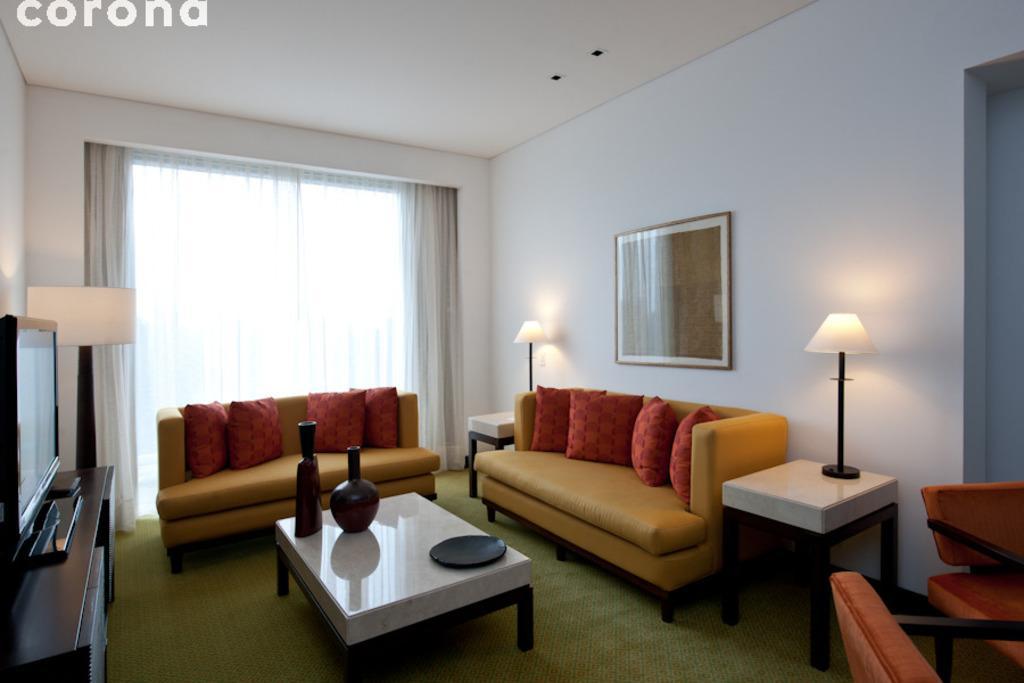How would you summarize this image in a sentence or two? in the picture we can see the living room in which sofas, tables ,table lamp and frame attached to the wall are present,here we can also see the curtains which is attached to the window,here we can also see an lcd screen present on the table. 